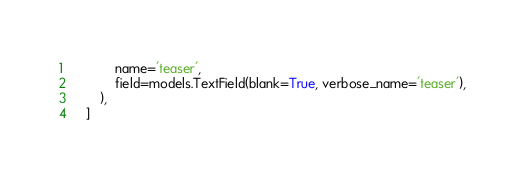Convert code to text. <code><loc_0><loc_0><loc_500><loc_500><_Python_>            name='teaser',
            field=models.TextField(blank=True, verbose_name='teaser'),
        ),
    ]
</code> 